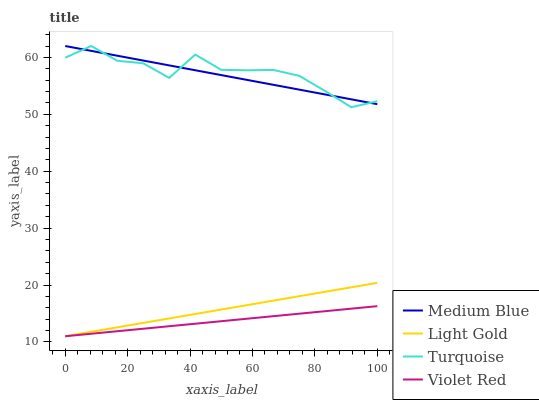Does Medium Blue have the minimum area under the curve?
Answer yes or no. No. Does Medium Blue have the maximum area under the curve?
Answer yes or no. No. Is Medium Blue the smoothest?
Answer yes or no. No. Is Medium Blue the roughest?
Answer yes or no. No. Does Turquoise have the lowest value?
Answer yes or no. No. Does Violet Red have the highest value?
Answer yes or no. No. Is Light Gold less than Turquoise?
Answer yes or no. Yes. Is Medium Blue greater than Light Gold?
Answer yes or no. Yes. Does Light Gold intersect Turquoise?
Answer yes or no. No. 